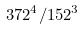<formula> <loc_0><loc_0><loc_500><loc_500>3 7 2 ^ { 4 } / 1 5 2 ^ { 3 }</formula> 